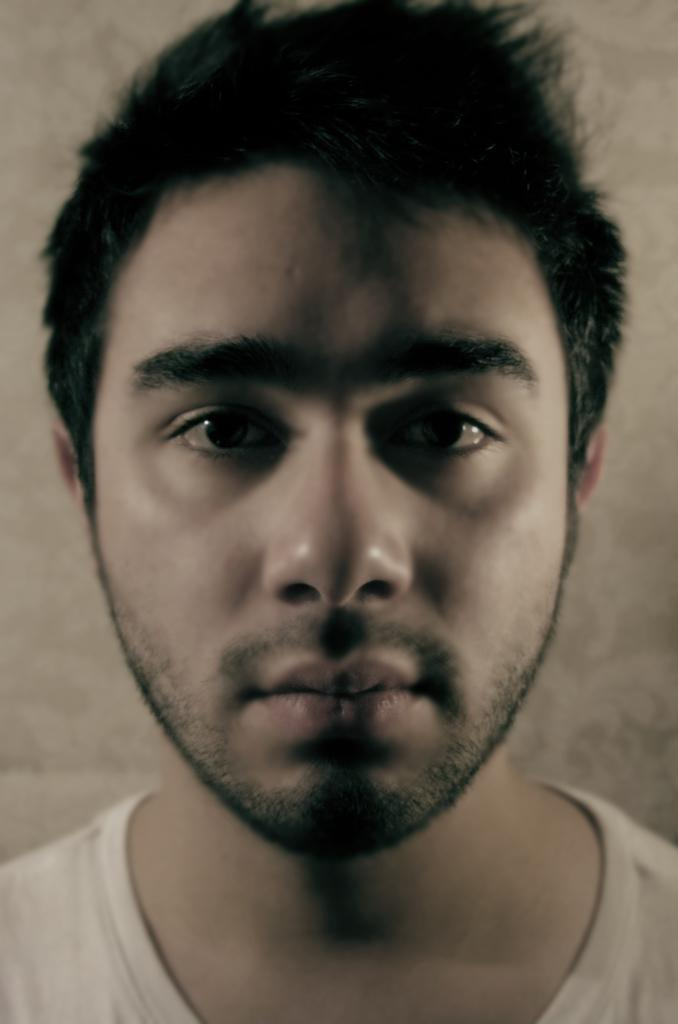What is present in the image? There is a person in the image. What can be seen in the background of the image? There is a well in the background of the image. What type of jelly can be seen on the person's thumb in the image? There is no jelly or thumb present in the image. 